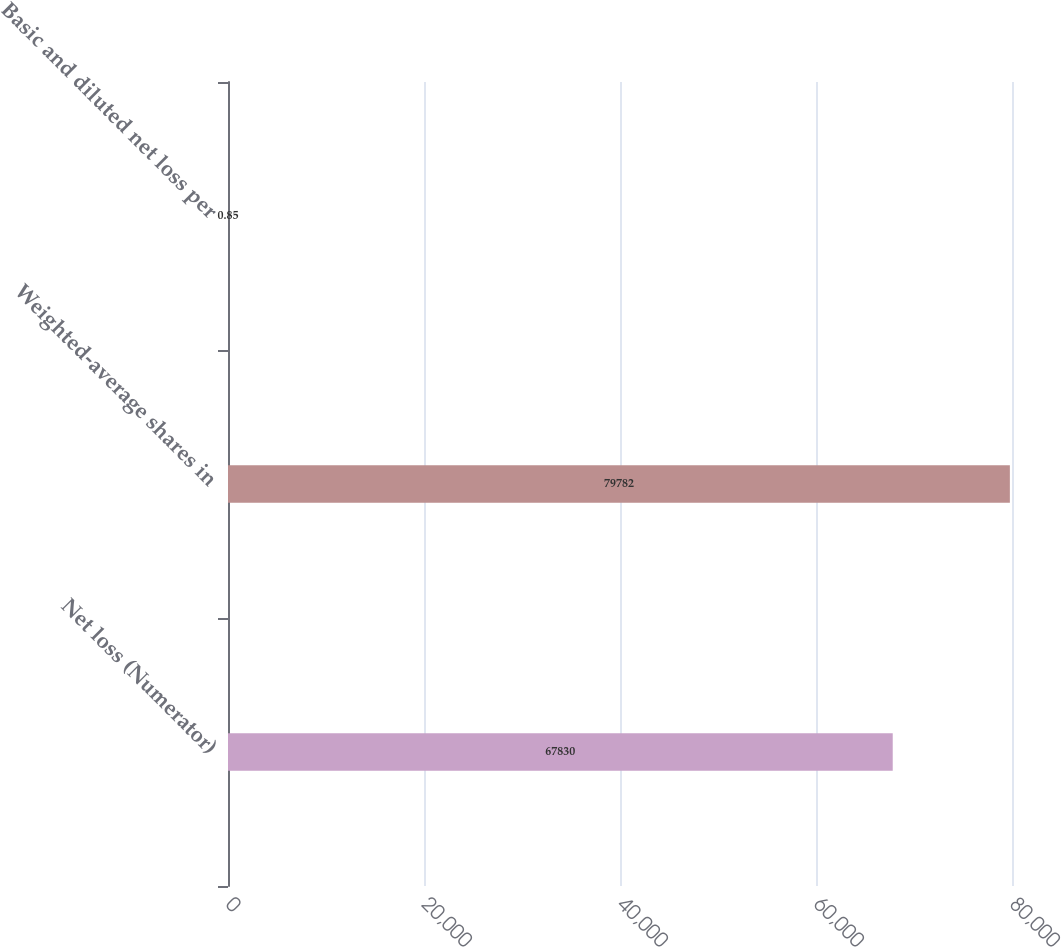Convert chart. <chart><loc_0><loc_0><loc_500><loc_500><bar_chart><fcel>Net loss (Numerator)<fcel>Weighted-average shares in<fcel>Basic and diluted net loss per<nl><fcel>67830<fcel>79782<fcel>0.85<nl></chart> 